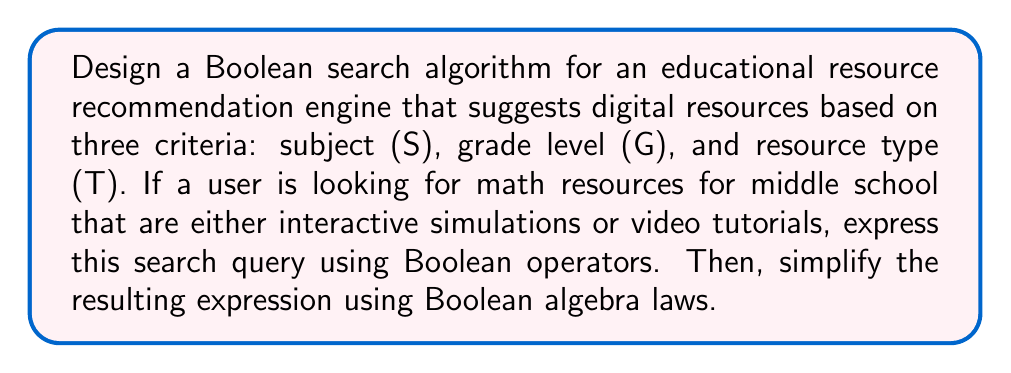Help me with this question. Let's approach this step-by-step:

1) First, we need to define our Boolean variables:
   $S$ = Math (Subject)
   $G$ = Middle School (Grade level)
   $T_1$ = Interactive Simulations (Resource type 1)
   $T_2$ = Video Tutorials (Resource type 2)

2) The initial Boolean expression for this search query would be:
   $$ S \land G \land (T_1 \lor T_2) $$

3) This expression is already in its simplest form according to Boolean algebra laws. However, let's verify this by applying some laws:

   a) Distributive Law: $A \land (B \lor C) = (A \land B) \lor (A \land C)$
      $$ S \land G \land (T_1 \lor T_2) = (S \land G \land T_1) \lor (S \land G \land T_2) $$

   b) Commutative Law: We can rearrange the order of terms
      $$ (S \land G \land T_1) \lor (S \land G \land T_2) = (S \land T_1 \land G) \lor (S \land T_2 \land G) $$

   c) Distributive Law again:
      $$ (S \land T_1 \land G) \lor (S \land T_2 \land G) = ((S \land T_1) \lor (S \land T_2)) \land G $$

   d) Distributive Law one more time:
      $$ ((S \land T_1) \lor (S \land T_2)) \land G = (S \land (T_1 \lor T_2)) \land G $$

   e) Associative Law: $(A \land B) \land C = A \land (B \land C)$
      $$ (S \land (T_1 \lor T_2)) \land G = S \land (T_1 \lor T_2) \land G $$

4) As we can see, we've arrived back at our original expression (just in a different order), confirming that it was already in its simplest form.
Answer: $S \land G \land (T_1 \lor T_2)$ 